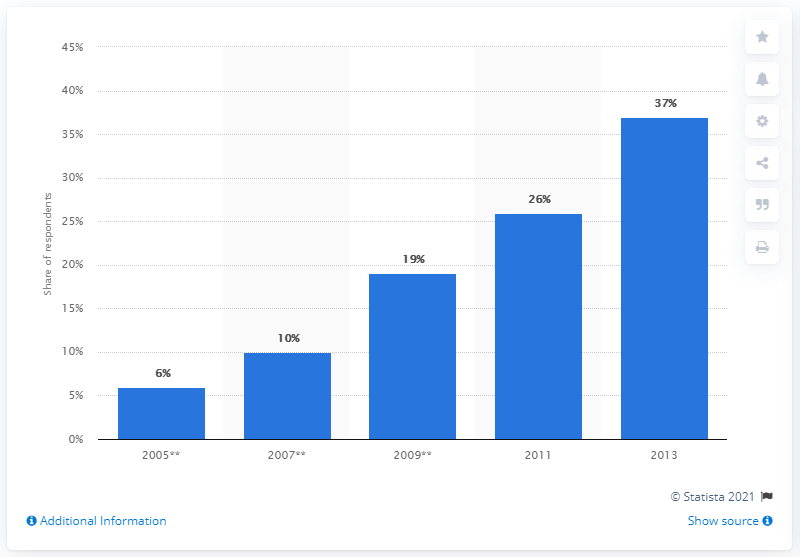Highlight a few significant elements in this photo. In 2013, the usage of tablet PCs experienced the most growth. The median of all the bars is 19. 